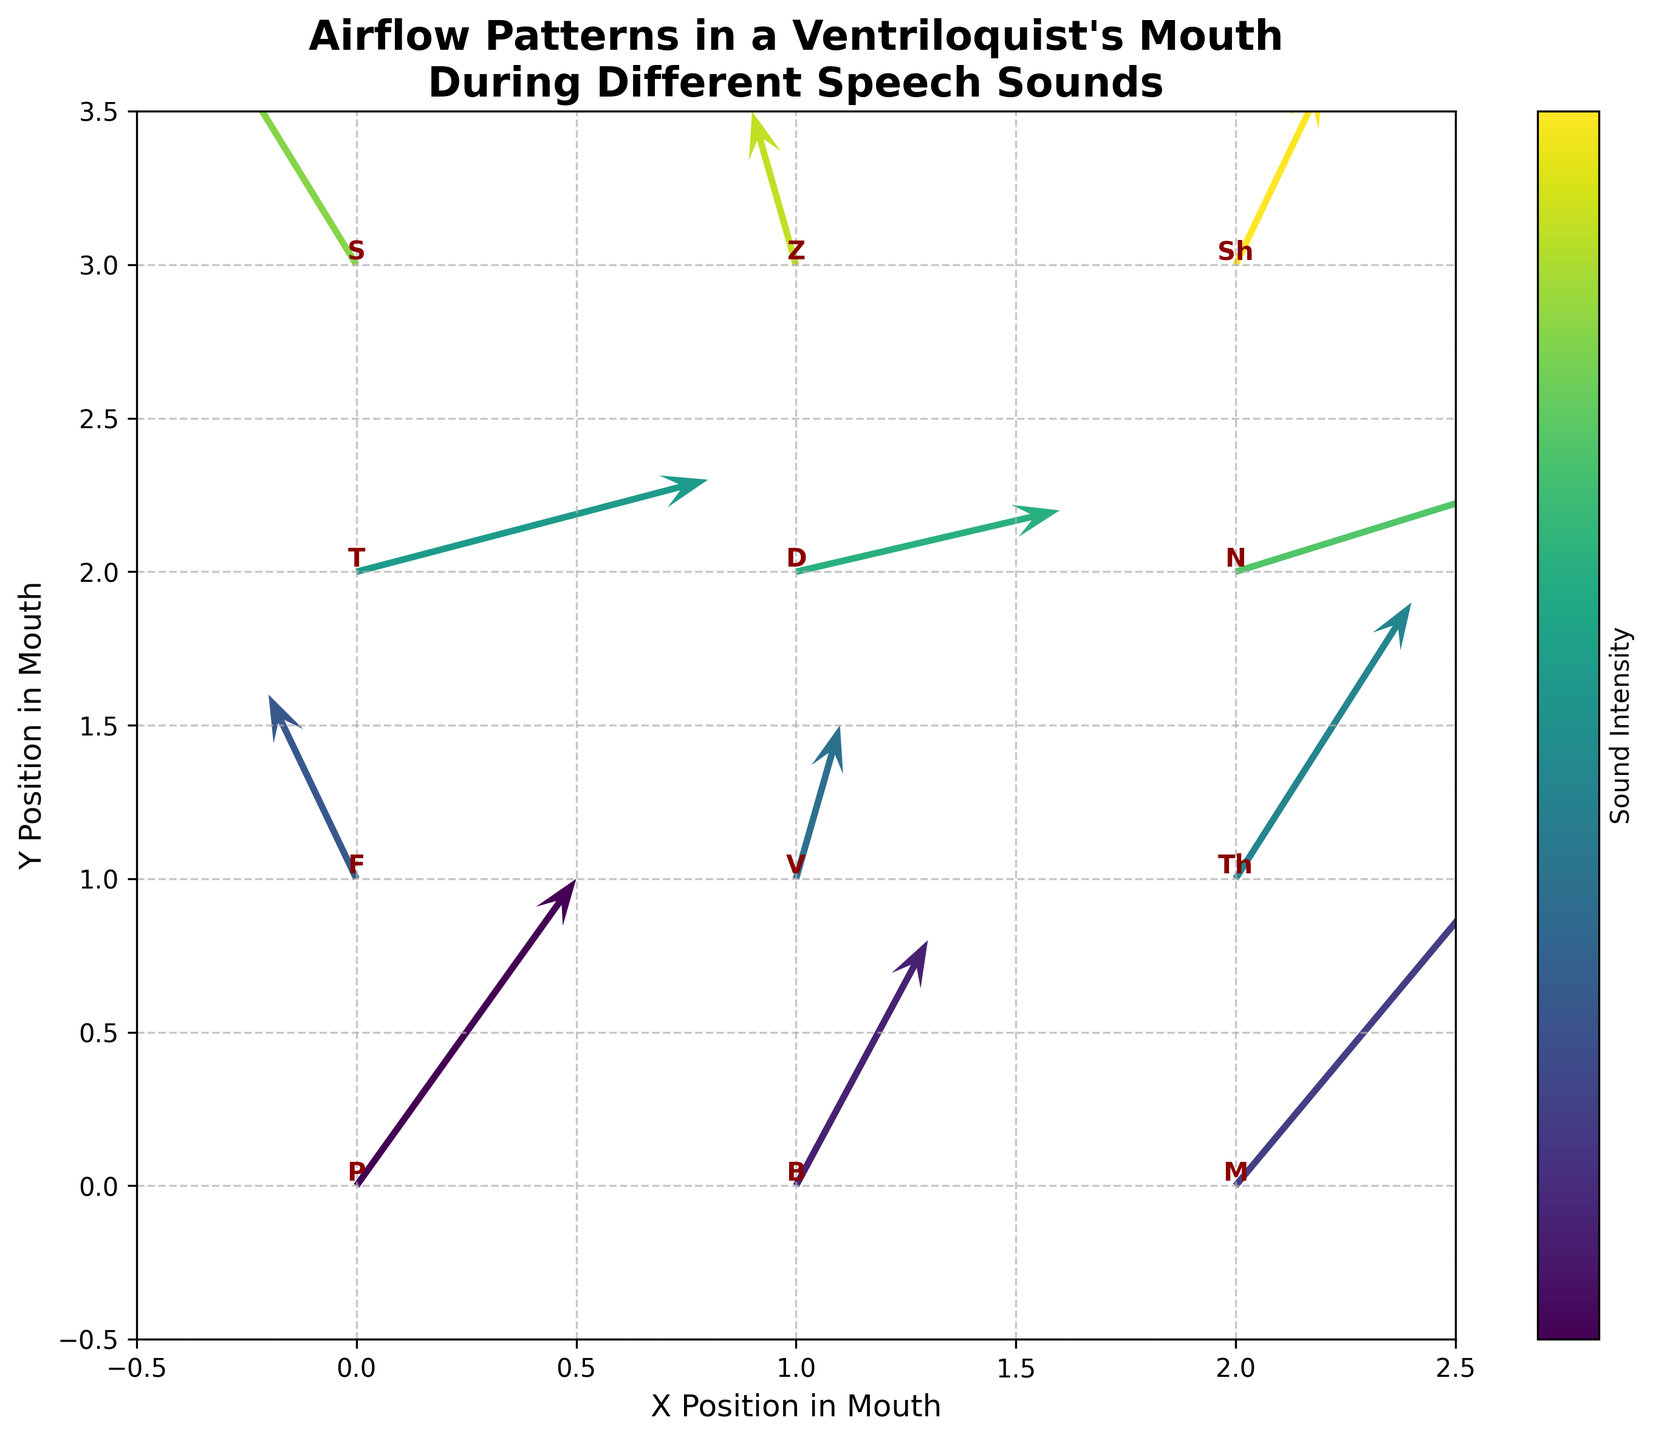What is the title of the plot? The title is usually placed at the top of the plot and provides a brief description of the figure. Here, it states "Airflow Patterns in a Ventriloquist's Mouth During Different Speech Sounds."
Answer: Airflow Patterns in a Ventriloquist's Mouth During Different Speech Sounds How many unique speech sounds are represented in the plot? By looking at the text labels next to each arrow in the quiver plot, we can count the unique speech sounds. The labels are: P, B, M, F, V, Th, T, D, N, S, Z, Sh.
Answer: 12 Which speech sound corresponds to the highest vertical airflow component? The vertical airflow component is represented by the length of the arrow along the y-axis. Looking for the longest arrow in the vertical direction, we see that it is associated with the sound "M."
Answer: M How does the airflow pattern for the sound "S" compare to "Sh"? To compare, we find the arrows labeled "S" and "Sh." For "S," the arrow points significantly upward with a slight negative x-component. For "Sh," the arrow points moderately upward with a small positive x-component. This shows a steeper vertical movement for "S" compared to "Sh."
Answer: "S" has a steeper vertical movement compared to "Sh." What is the total number of data points plotted in the figure? Each data point corresponds to an airflow pattern represented by an arrow and its associated label (speech sound). Counting each arrow and label, we see there are multiple data points spread across different positions in the plot. There are 12 arrows, so there are 12 data points.
Answer: 12 Which speech sound is associated with an airflow primarily in the negative x-direction? Looking at the direction of the arrows for each sound, the sound "S" at (0,3) has an arrow pointing primarily in the negative x-direction. This indicates that the majority of the flow is to the left.
Answer: S For the sound "T," what are the x and y components of the airflow? Locate the label "T" on the plot and read the corresponding x and y components of the airflow from the arrow. The airflow components are given as: u = 0.8 (x-direction) and v = 0.3 (y-direction).
Answer: u = 0.8, v = 0.3 Are there more sounds with a positive x-component or negative x-component of airflow? By examining the direction of each arrow’s x-component, we count the ones pointing to the right (positive) and the ones pointing to the left (negative). There are 10 arrows with a positive x-component (P, B, M, V, Th, T, D, N, Z, Sh) and 2 with a negative x-component (F, S).
Answer: More positive x-components Which speech sound displays the least amount of airflow movement overall? Comparing the length of each arrow in the plot gives us an idea of overall airflow movement. The shortest arrow represents the least movement, which is labeled "D" at (1,2) with components u = 0.6, v = 0.2.
Answer: D What is the average vertical airflow component for the speech sounds located at y = 2? The speech sounds at y = 2 are T, D, and N. Their vertical components are v = 0.3, v = 0.2, and v = 0.4 respectively. Averaging these gives (0.3 + 0.2 + 0.4) / 3 = 0.3.
Answer: 0.3 